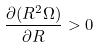Convert formula to latex. <formula><loc_0><loc_0><loc_500><loc_500>\frac { \partial ( R ^ { 2 } \Omega ) } { \partial R } > 0</formula> 